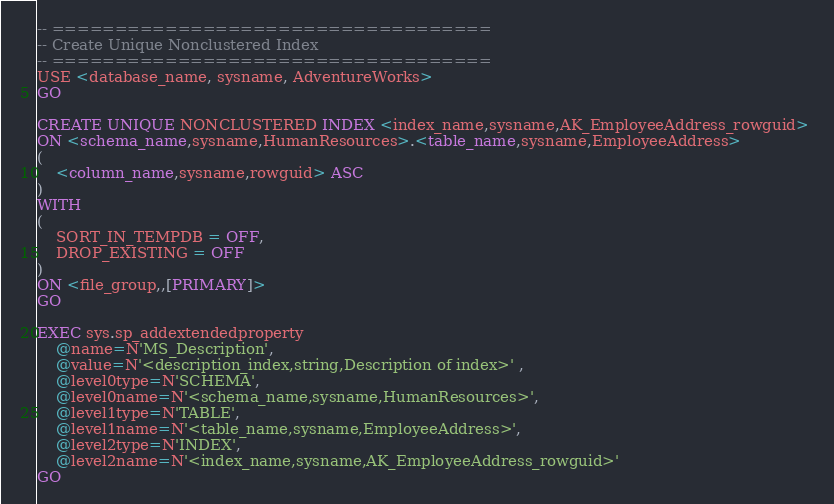<code> <loc_0><loc_0><loc_500><loc_500><_SQL_>-- ===================================
-- Create Unique Nonclustered Index
-- ===================================
USE <database_name, sysname, AdventureWorks>
GO

CREATE UNIQUE NONCLUSTERED INDEX <index_name,sysname,AK_EmployeeAddress_rowguid> 
ON <schema_name,sysname,HumanResources>.<table_name,sysname,EmployeeAddress> 
(
	<column_name,sysname,rowguid> ASC
)
WITH 
(
	SORT_IN_TEMPDB = OFF, 
	DROP_EXISTING = OFF
) 
ON <file_group,,[PRIMARY]>
GO

EXEC sys.sp_addextendedproperty 
	@name=N'MS_Description', 
	@value=N'<description_index,string,Description of index>' ,
	@level0type=N'SCHEMA', 
	@level0name=N'<schema_name,sysname,HumanResources>', 
	@level1type=N'TABLE', 
	@level1name=N'<table_name,sysname,EmployeeAddress>', 
	@level2type=N'INDEX', 
	@level2name=N'<index_name,sysname,AK_EmployeeAddress_rowguid>'
GO
</code> 